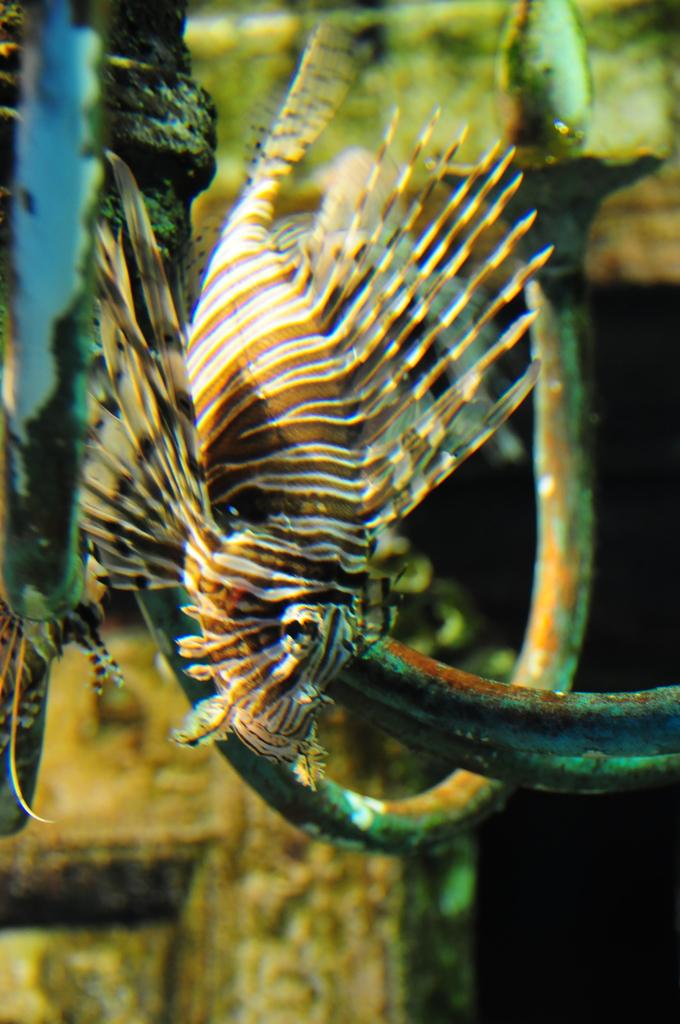What is the main subject of the image? There is a fish swimming in the water. What object can be seen in the image besides the fish? There is a metal hook in the image. Can you describe the background of the image? There is an object in the backdrop of the image. What type of ball is being used by the duck in the image? There is no ball or duck present in the image; it features a fish swimming in the water and a metal hook. Where is the faucet located in the image? There is no faucet present in the image. 